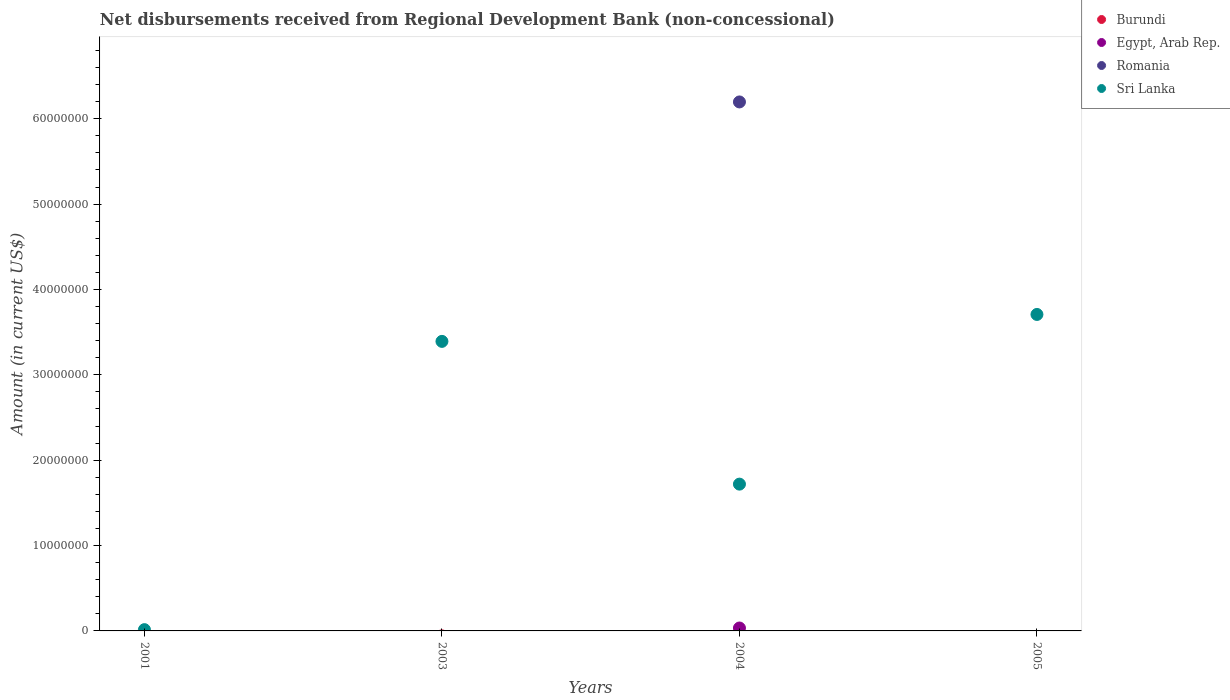Is the number of dotlines equal to the number of legend labels?
Offer a terse response. No. What is the amount of disbursements received from Regional Development Bank in Burundi in 2004?
Provide a short and direct response. 0. Across all years, what is the maximum amount of disbursements received from Regional Development Bank in Egypt, Arab Rep.?
Provide a short and direct response. 3.41e+05. Across all years, what is the minimum amount of disbursements received from Regional Development Bank in Sri Lanka?
Ensure brevity in your answer.  1.50e+05. In which year was the amount of disbursements received from Regional Development Bank in Egypt, Arab Rep. maximum?
Your answer should be compact. 2004. What is the total amount of disbursements received from Regional Development Bank in Egypt, Arab Rep. in the graph?
Your response must be concise. 3.41e+05. What is the difference between the amount of disbursements received from Regional Development Bank in Sri Lanka in 2001 and that in 2003?
Give a very brief answer. -3.38e+07. What is the difference between the amount of disbursements received from Regional Development Bank in Sri Lanka in 2003 and the amount of disbursements received from Regional Development Bank in Egypt, Arab Rep. in 2005?
Offer a very short reply. 3.39e+07. What is the average amount of disbursements received from Regional Development Bank in Burundi per year?
Offer a terse response. 0. In the year 2004, what is the difference between the amount of disbursements received from Regional Development Bank in Egypt, Arab Rep. and amount of disbursements received from Regional Development Bank in Romania?
Provide a succinct answer. -6.16e+07. In how many years, is the amount of disbursements received from Regional Development Bank in Sri Lanka greater than 16000000 US$?
Your answer should be very brief. 3. What is the ratio of the amount of disbursements received from Regional Development Bank in Sri Lanka in 2001 to that in 2004?
Your response must be concise. 0.01. What is the difference between the highest and the second highest amount of disbursements received from Regional Development Bank in Sri Lanka?
Keep it short and to the point. 3.16e+06. What is the difference between the highest and the lowest amount of disbursements received from Regional Development Bank in Romania?
Give a very brief answer. 6.20e+07. In how many years, is the amount of disbursements received from Regional Development Bank in Romania greater than the average amount of disbursements received from Regional Development Bank in Romania taken over all years?
Provide a succinct answer. 1. Is the sum of the amount of disbursements received from Regional Development Bank in Sri Lanka in 2003 and 2005 greater than the maximum amount of disbursements received from Regional Development Bank in Romania across all years?
Your answer should be very brief. Yes. How many dotlines are there?
Offer a very short reply. 3. What is the difference between two consecutive major ticks on the Y-axis?
Keep it short and to the point. 1.00e+07. Does the graph contain any zero values?
Keep it short and to the point. Yes. Does the graph contain grids?
Your answer should be very brief. No. Where does the legend appear in the graph?
Give a very brief answer. Top right. How many legend labels are there?
Provide a short and direct response. 4. What is the title of the graph?
Your answer should be very brief. Net disbursements received from Regional Development Bank (non-concessional). Does "Niger" appear as one of the legend labels in the graph?
Offer a very short reply. No. What is the label or title of the X-axis?
Keep it short and to the point. Years. What is the Amount (in current US$) of Burundi in 2001?
Provide a short and direct response. 0. What is the Amount (in current US$) in Egypt, Arab Rep. in 2001?
Ensure brevity in your answer.  0. What is the Amount (in current US$) of Romania in 2001?
Make the answer very short. 0. What is the Amount (in current US$) of Egypt, Arab Rep. in 2003?
Your answer should be compact. 0. What is the Amount (in current US$) in Romania in 2003?
Provide a succinct answer. 0. What is the Amount (in current US$) of Sri Lanka in 2003?
Your answer should be compact. 3.39e+07. What is the Amount (in current US$) of Burundi in 2004?
Ensure brevity in your answer.  0. What is the Amount (in current US$) of Egypt, Arab Rep. in 2004?
Make the answer very short. 3.41e+05. What is the Amount (in current US$) of Romania in 2004?
Offer a terse response. 6.20e+07. What is the Amount (in current US$) in Sri Lanka in 2004?
Keep it short and to the point. 1.72e+07. What is the Amount (in current US$) of Egypt, Arab Rep. in 2005?
Offer a very short reply. 0. What is the Amount (in current US$) of Sri Lanka in 2005?
Provide a succinct answer. 3.71e+07. Across all years, what is the maximum Amount (in current US$) of Egypt, Arab Rep.?
Make the answer very short. 3.41e+05. Across all years, what is the maximum Amount (in current US$) in Romania?
Your response must be concise. 6.20e+07. Across all years, what is the maximum Amount (in current US$) of Sri Lanka?
Offer a very short reply. 3.71e+07. Across all years, what is the minimum Amount (in current US$) of Egypt, Arab Rep.?
Your answer should be compact. 0. What is the total Amount (in current US$) of Egypt, Arab Rep. in the graph?
Give a very brief answer. 3.41e+05. What is the total Amount (in current US$) of Romania in the graph?
Offer a terse response. 6.20e+07. What is the total Amount (in current US$) in Sri Lanka in the graph?
Your answer should be compact. 8.83e+07. What is the difference between the Amount (in current US$) in Sri Lanka in 2001 and that in 2003?
Keep it short and to the point. -3.38e+07. What is the difference between the Amount (in current US$) in Sri Lanka in 2001 and that in 2004?
Your response must be concise. -1.70e+07. What is the difference between the Amount (in current US$) of Sri Lanka in 2001 and that in 2005?
Give a very brief answer. -3.69e+07. What is the difference between the Amount (in current US$) in Sri Lanka in 2003 and that in 2004?
Your answer should be very brief. 1.67e+07. What is the difference between the Amount (in current US$) of Sri Lanka in 2003 and that in 2005?
Offer a very short reply. -3.16e+06. What is the difference between the Amount (in current US$) of Sri Lanka in 2004 and that in 2005?
Make the answer very short. -1.99e+07. What is the difference between the Amount (in current US$) of Egypt, Arab Rep. in 2004 and the Amount (in current US$) of Sri Lanka in 2005?
Give a very brief answer. -3.67e+07. What is the difference between the Amount (in current US$) in Romania in 2004 and the Amount (in current US$) in Sri Lanka in 2005?
Provide a succinct answer. 2.49e+07. What is the average Amount (in current US$) of Burundi per year?
Give a very brief answer. 0. What is the average Amount (in current US$) of Egypt, Arab Rep. per year?
Make the answer very short. 8.52e+04. What is the average Amount (in current US$) of Romania per year?
Keep it short and to the point. 1.55e+07. What is the average Amount (in current US$) in Sri Lanka per year?
Make the answer very short. 2.21e+07. In the year 2004, what is the difference between the Amount (in current US$) in Egypt, Arab Rep. and Amount (in current US$) in Romania?
Keep it short and to the point. -6.16e+07. In the year 2004, what is the difference between the Amount (in current US$) in Egypt, Arab Rep. and Amount (in current US$) in Sri Lanka?
Ensure brevity in your answer.  -1.69e+07. In the year 2004, what is the difference between the Amount (in current US$) of Romania and Amount (in current US$) of Sri Lanka?
Offer a terse response. 4.48e+07. What is the ratio of the Amount (in current US$) of Sri Lanka in 2001 to that in 2003?
Keep it short and to the point. 0. What is the ratio of the Amount (in current US$) in Sri Lanka in 2001 to that in 2004?
Make the answer very short. 0.01. What is the ratio of the Amount (in current US$) in Sri Lanka in 2001 to that in 2005?
Your answer should be very brief. 0. What is the ratio of the Amount (in current US$) of Sri Lanka in 2003 to that in 2004?
Offer a very short reply. 1.97. What is the ratio of the Amount (in current US$) of Sri Lanka in 2003 to that in 2005?
Give a very brief answer. 0.91. What is the ratio of the Amount (in current US$) in Sri Lanka in 2004 to that in 2005?
Provide a short and direct response. 0.46. What is the difference between the highest and the second highest Amount (in current US$) of Sri Lanka?
Your answer should be very brief. 3.16e+06. What is the difference between the highest and the lowest Amount (in current US$) in Egypt, Arab Rep.?
Ensure brevity in your answer.  3.41e+05. What is the difference between the highest and the lowest Amount (in current US$) in Romania?
Your answer should be compact. 6.20e+07. What is the difference between the highest and the lowest Amount (in current US$) in Sri Lanka?
Your response must be concise. 3.69e+07. 